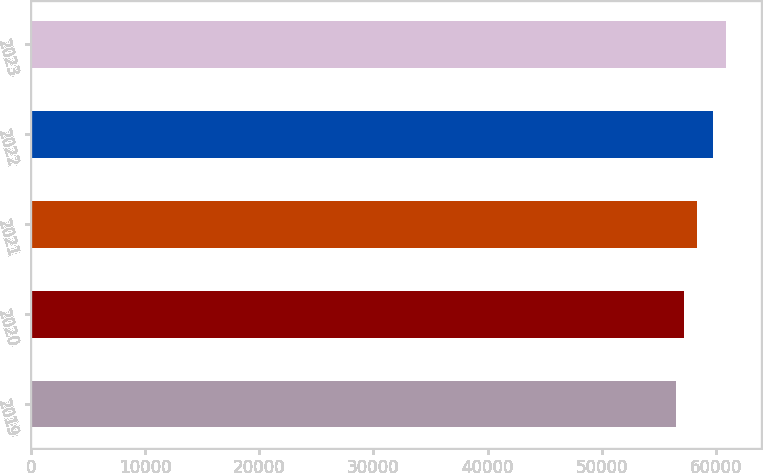Convert chart to OTSL. <chart><loc_0><loc_0><loc_500><loc_500><bar_chart><fcel>2019<fcel>2020<fcel>2021<fcel>2022<fcel>2023<nl><fcel>56493<fcel>57191<fcel>58317<fcel>59705<fcel>60871<nl></chart> 